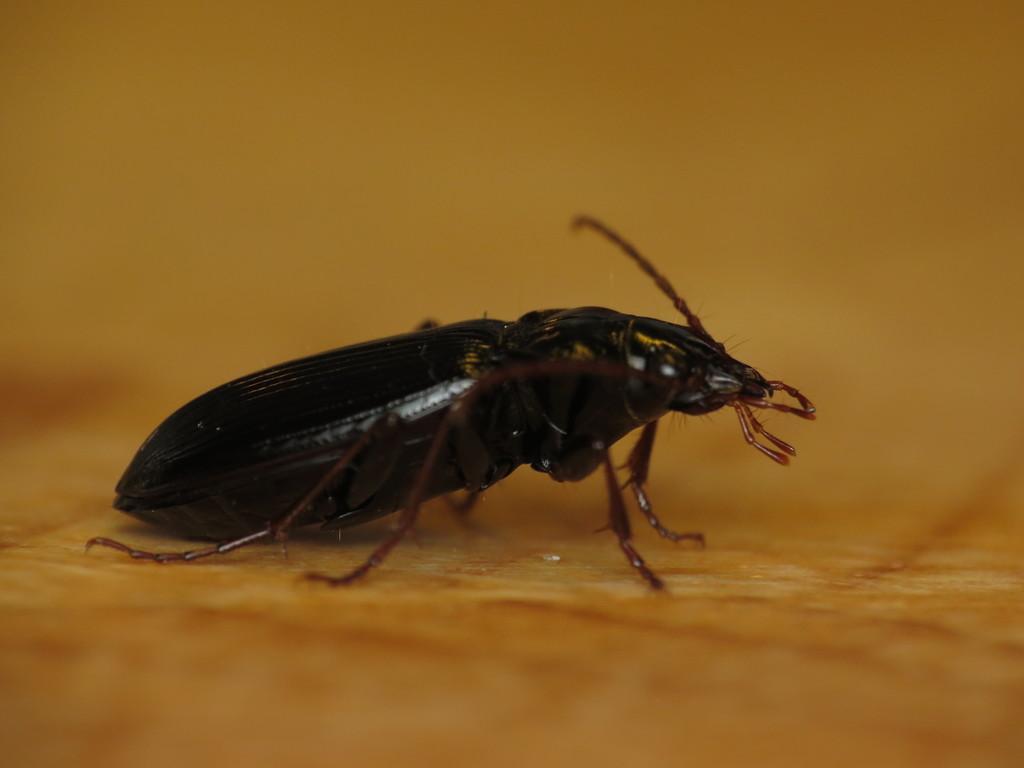Describe this image in one or two sentences. In this picture we can see an insect. 